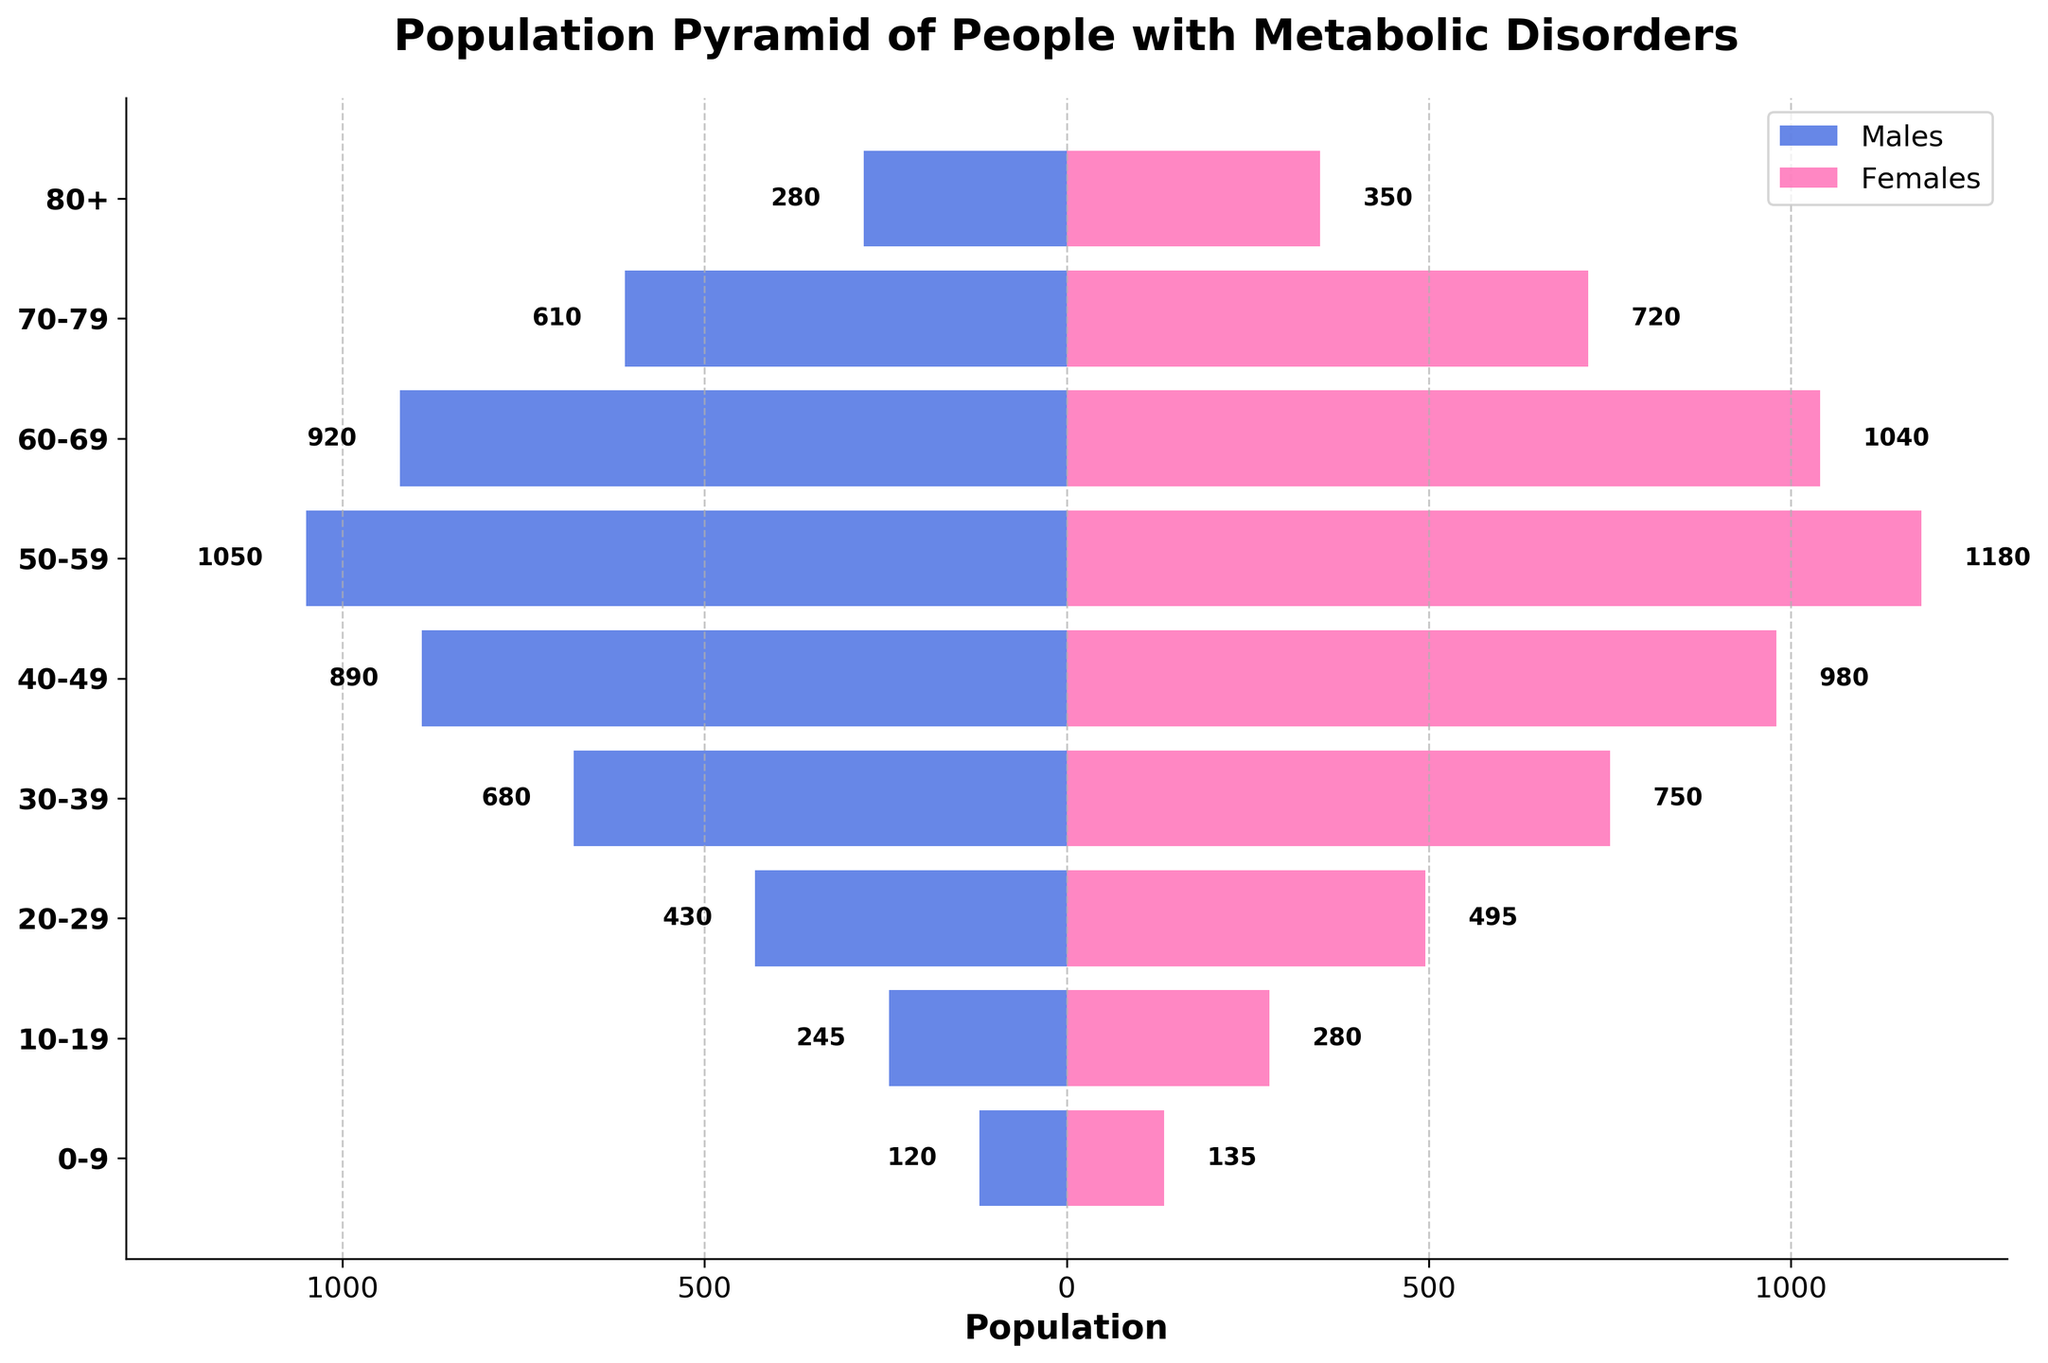What is the title of the figure? The title of the figure is typically found at the top center and often written in a large, bold font. In this figure, it reads "Population Pyramid of People with Metabolic Disorders".
Answer: Population Pyramid of People with Metabolic Disorders Which age group has the highest number of males? To find this, we look at the length of blue bars (representing males) in each age group. The longest bar indicates the highest number, which corresponds to the 50-59 age group.
Answer: 50-59 How many more females are there in the 50-59 age group compared to males? Check the length of the pink bar for females and the blue bar for males in the 50-59 age group. There are 1,180 females and 1,050 males. Subtract the number of males from females: 1180 - 1050 = 130.
Answer: 130 Which age group has the smallest population difference between males and females? To determine this, calculate the absolute difference between the number of males and females for each age group. The 10-19 age group has the smallest difference: 280 (females) - 245 (males) = 35.
Answer: 10-19 What is the total number of people in the 30-39 age group? Add the number of males and females in the 30-39 age group: 680 (males) + 750 (females) = 1430.
Answer: 1430 In which age group does the population of females start to decrease compared to the previous age group? Observe the trend of the pink bars representing females. The population starts to decrease in the 60-69 age group compared to the 50-59 age group: 1040 (60-69) < 1180 (50-59).
Answer: 60-69 Are there more males or females in the 70-79 age group? Compare the lengths of the blue bar (males) and pink bar (females) in the 70-79 age group. There are 610 males and 720 females; thus, there are more females.
Answer: Females What is the total number of children (age 0-9) in the population? Add the number of males and females in the 0-9 age group: 120 (males) + 135 (females) = 255.
Answer: 255 How does the population of the 40-49 age group compare to the 60-69 age group? Add the males and females for both age groups. 40-49: 890 (males) + 980 (females) = 1870. 60-69: 920 (males) + 1040 (females) = 1960. The 60-69 age group has a higher population.
Answer: 60-69 has a higher population Which gender has the overall higher population in the dataset? Sum the total number of males and females across all age groups. Males: 120 + 245 + 430 + 680 + 890 + 1050 + 920 + 610 + 280 = 5225. Females: 135 + 280 + 495 + 750 + 980 + 1180 + 1040 + 720 + 350 = 5930. There are more females overall.
Answer: Females 